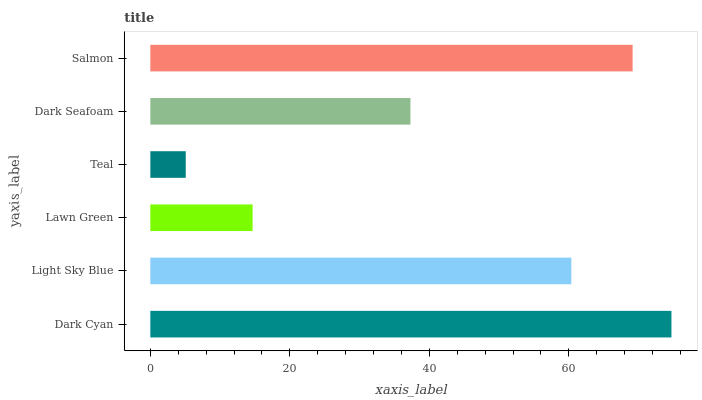Is Teal the minimum?
Answer yes or no. Yes. Is Dark Cyan the maximum?
Answer yes or no. Yes. Is Light Sky Blue the minimum?
Answer yes or no. No. Is Light Sky Blue the maximum?
Answer yes or no. No. Is Dark Cyan greater than Light Sky Blue?
Answer yes or no. Yes. Is Light Sky Blue less than Dark Cyan?
Answer yes or no. Yes. Is Light Sky Blue greater than Dark Cyan?
Answer yes or no. No. Is Dark Cyan less than Light Sky Blue?
Answer yes or no. No. Is Light Sky Blue the high median?
Answer yes or no. Yes. Is Dark Seafoam the low median?
Answer yes or no. Yes. Is Salmon the high median?
Answer yes or no. No. Is Teal the low median?
Answer yes or no. No. 